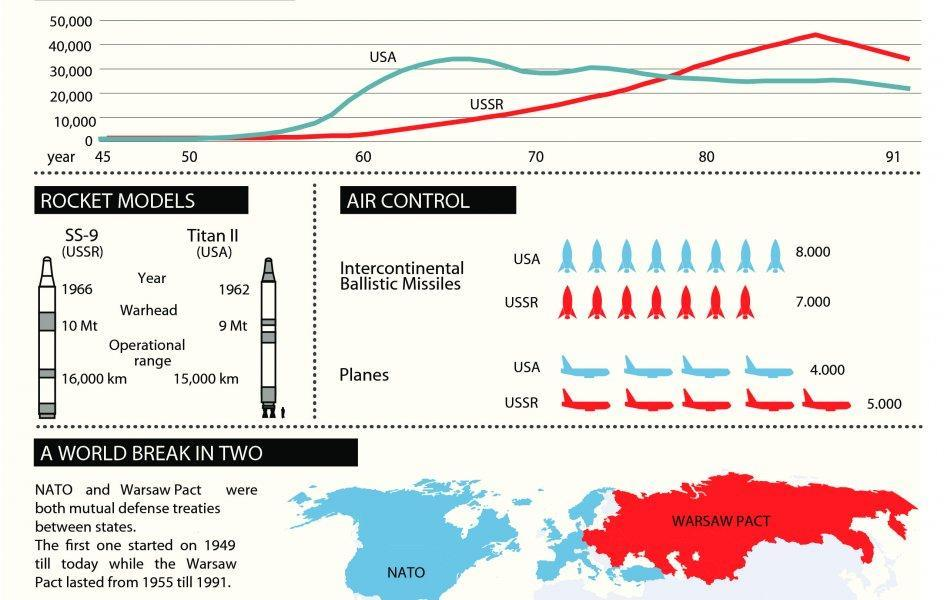When was Warsaw pact formed?
Answer the question with a short phrase. 1955 How many intercontinental ballistic missiles were deployed in NATO forces by the USA? 8,000 When did the US launch Titan II? 1962 What is the warhead length of Titan II? 9 Mt What is the number of aircraft planes deployed in Warsaw Pact forces by the USSR? 5,000 What is the operational range of SS-9? 16,000 km 